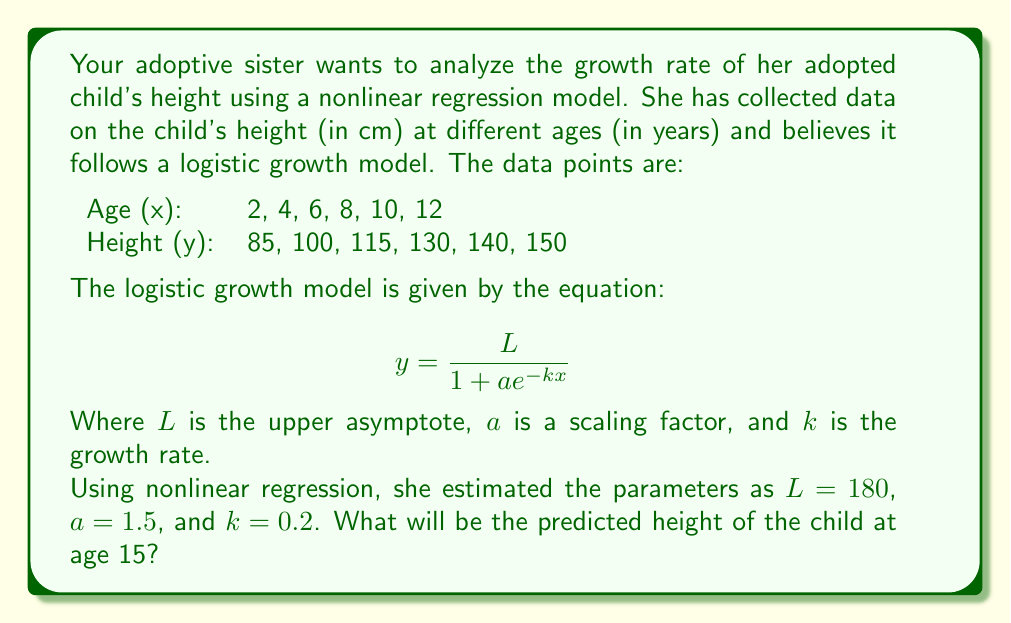Teach me how to tackle this problem. To solve this problem, we'll follow these steps:

1. Understand the logistic growth model:
   The model is given by $$ y = \frac{L}{1 + ae^{-kx}} $$
   where $y$ is the height, $x$ is the age, and $L$, $a$, and $k$ are parameters.

2. Identify the given parameters:
   $L = 180$ (upper asymptote)
   $a = 1.5$ (scaling factor)
   $k = 0.2$ (growth rate)

3. Substitute the age we want to predict (x = 15) and the given parameters into the equation:

   $$ y = \frac{180}{1 + 1.5e^{-0.2(15)}} $$

4. Simplify the expression in the exponent:
   $-0.2(15) = -3$

5. Calculate the value of $e^{-3}$:
   $e^{-3} \approx 0.0497$

6. Substitute this value back into the equation:
   $$ y = \frac{180}{1 + 1.5(0.0497)} $$

7. Simplify:
   $$ y = \frac{180}{1 + 0.07455} = \frac{180}{1.07455} $$

8. Perform the division:
   $y \approx 167.51$ cm

Therefore, the predicted height of the child at age 15 is approximately 167.51 cm.
Answer: 167.51 cm 